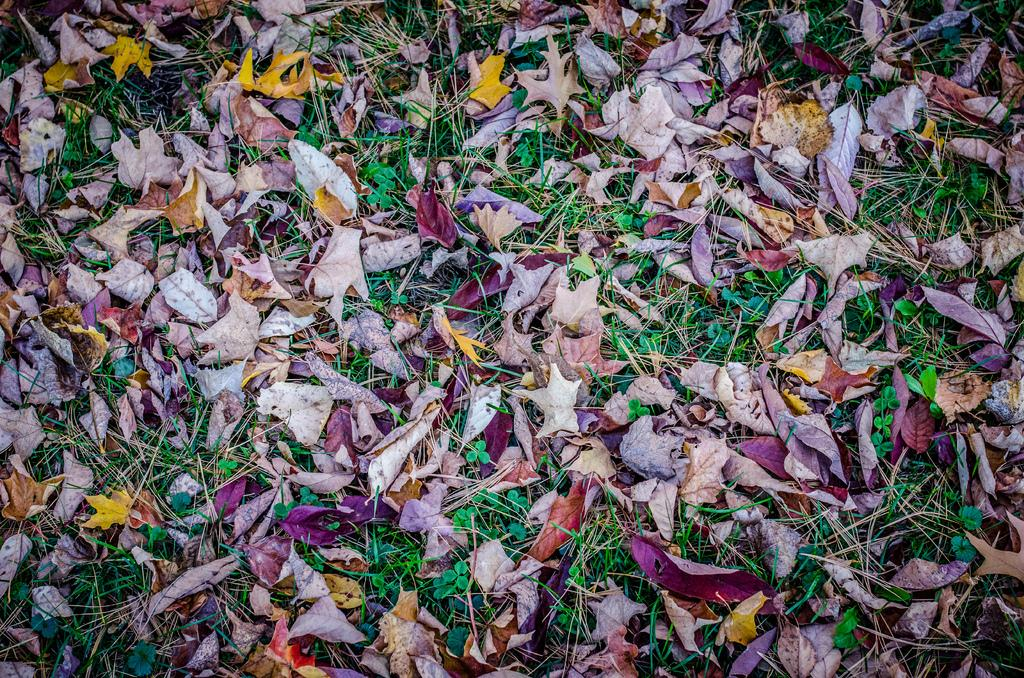What type of vegetation can be seen in the image? There are many dry leaves and grass visible in the image. What else is present on the ground in the image? There are plants on the ground in the image. How does the rake feel about the loss of its handle in the image? There is no rake present in the image, so it is not possible to determine how it might feel about any loss. 